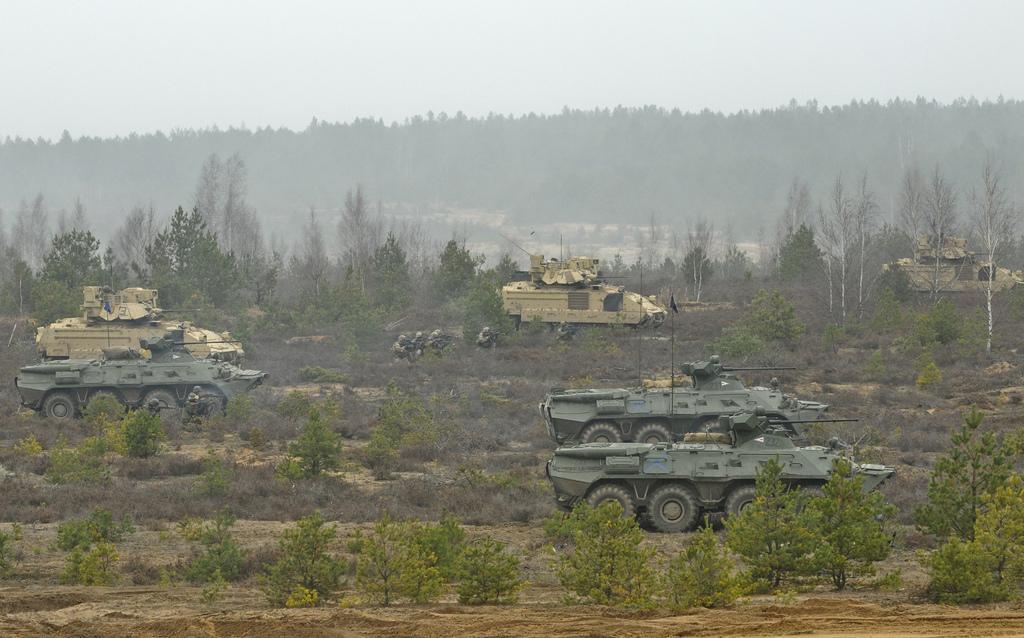Can you describe this image briefly? In this image we can see military vehicles, plants, trees and sky. 